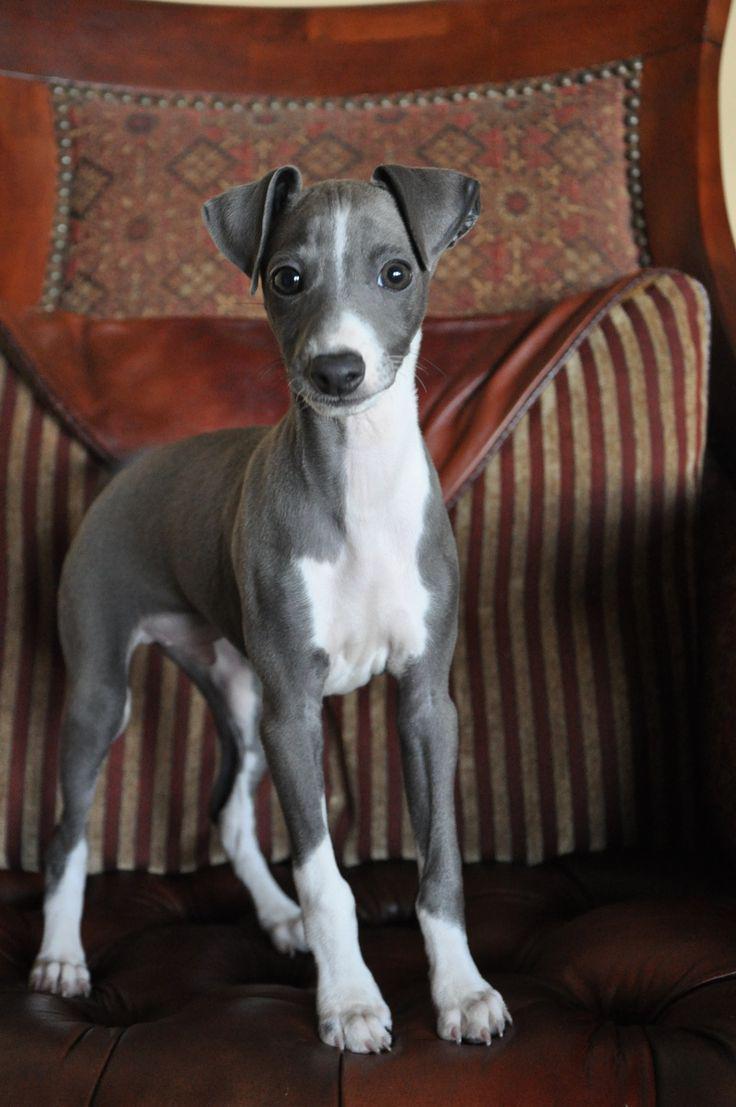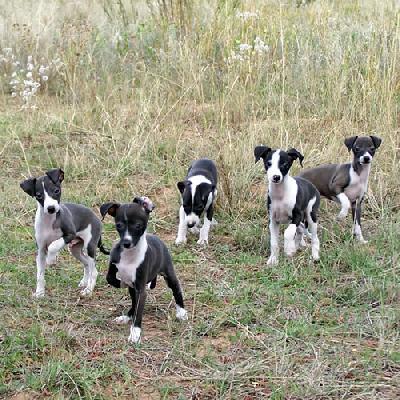The first image is the image on the left, the second image is the image on the right. Considering the images on both sides, is "One image contains only one dog, while the other image contains at least 5 dogs." valid? Answer yes or no. Yes. The first image is the image on the left, the second image is the image on the right. Evaluate the accuracy of this statement regarding the images: "One image contains a single dog, which is looking at the camera while in a standing pose indoors.". Is it true? Answer yes or no. Yes. 